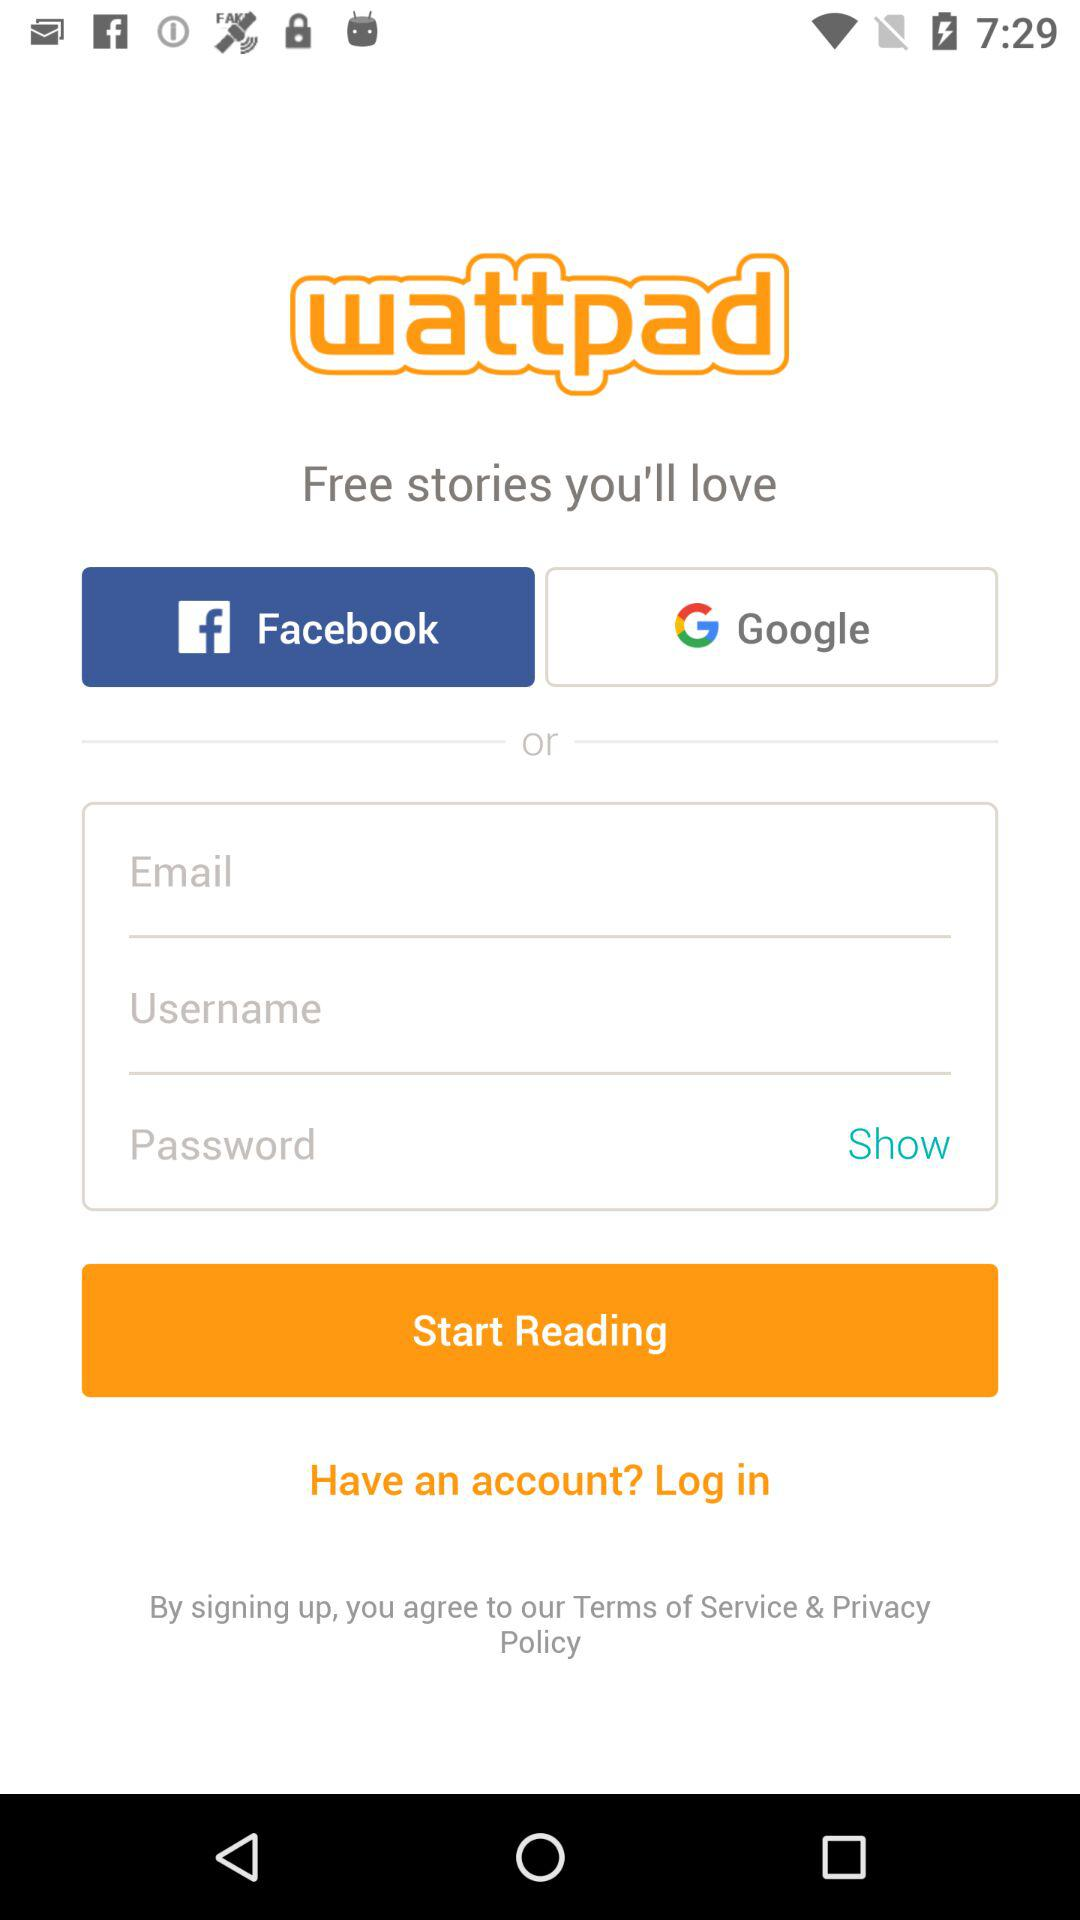What is the user's email?
When the provided information is insufficient, respond with <no answer>. <no answer> 